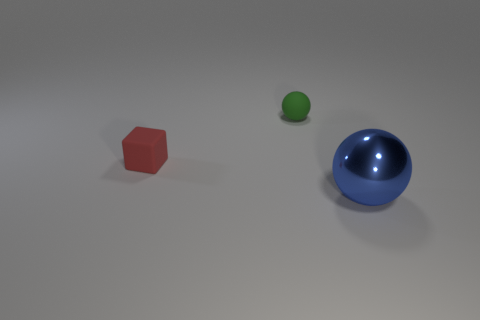Add 2 red rubber things. How many objects exist? 5 Subtract all blue balls. How many balls are left? 1 Subtract 1 cubes. How many cubes are left? 0 Add 2 red blocks. How many red blocks are left? 3 Add 1 blue balls. How many blue balls exist? 2 Subtract 0 blue blocks. How many objects are left? 3 Subtract all balls. How many objects are left? 1 Subtract all blue balls. Subtract all gray cylinders. How many balls are left? 1 Subtract all brown cylinders. How many blue balls are left? 1 Subtract all gray shiny blocks. Subtract all tiny matte objects. How many objects are left? 1 